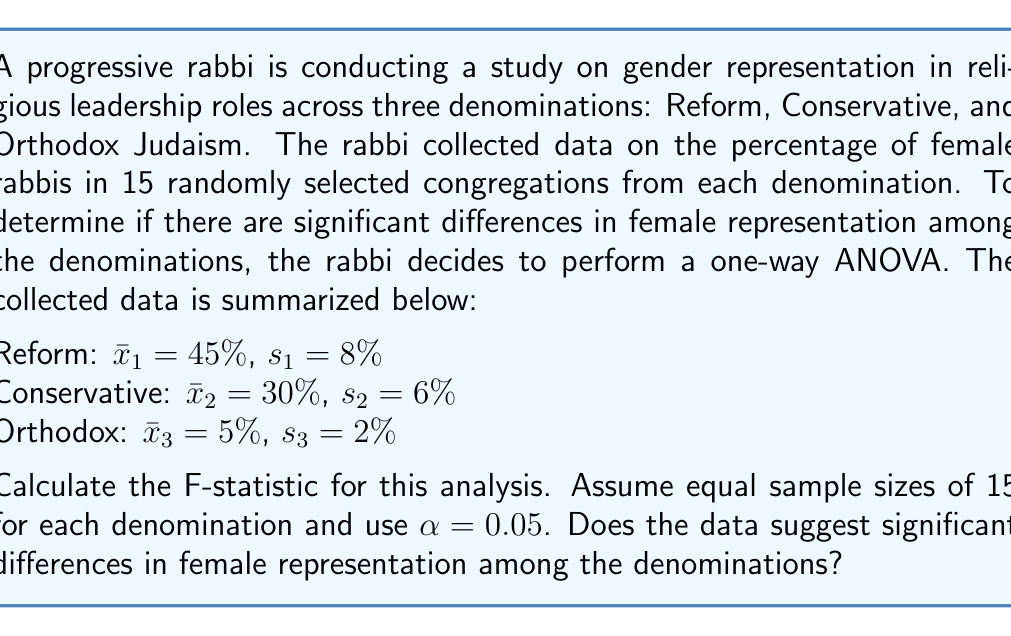Can you answer this question? To calculate the F-statistic and determine if there are significant differences in female representation among the denominations, we'll follow these steps:

1. Calculate the between-group sum of squares (SSB)
2. Calculate the within-group sum of squares (SSW)
3. Calculate the F-statistic
4. Compare the F-statistic to the critical F-value

Step 1: Calculate SSB
SSB = $n \sum_{i=1}^k (\bar{x}_i - \bar{x})^2$

Where:
$n$ = sample size per group = 15
$k$ = number of groups = 3
$\bar{x}$ = grand mean = $\frac{45 + 30 + 5}{3} = 26.67\%$

SSB = $15 [(45 - 26.67)^2 + (30 - 26.67)^2 + (5 - 26.67)^2]$
SSB = $15 [336.11 + 11.11 + 469.44]$
SSB = $15 \times 816.66 = 12,249.90$

Step 2: Calculate SSW
SSW = $\sum_{i=1}^k (n_i - 1)s_i^2$

Where $n_i$ = sample size of each group = 15

SSW = $(15 - 1)(8^2) + (15 - 1)(6^2) + (15 - 1)(2^2)$
SSW = $14(64 + 36 + 4)$
SSW = $14 \times 104 = 1,456$

Step 3: Calculate F-statistic
$F = \frac{MSB}{MSW} = \frac{SSB / (k-1)}{SSW / (N-k)}$

Where:
$k$ = number of groups = 3
$N$ = total sample size = $15 \times 3 = 45$

$F = \frac{12,249.90 / (3-1)}{1,456 / (45-3)} = \frac{6,124.95}{34.67} = 176.67$

Step 4: Compare to critical F-value
Degrees of freedom: $df_1 = k - 1 = 2$, $df_2 = N - k = 42$
Critical F-value for $\alpha = 0.05$, $F_{2,42} \approx 3.22$ (from F-distribution table)

Since the calculated F-statistic (176.67) is much larger than the critical F-value (3.22), we reject the null hypothesis.
Answer: The calculated F-statistic is 176.67. Since this value is much larger than the critical F-value of 3.22, we conclude that there are significant differences in female representation among the denominations at the $\alpha = 0.05$ level. 